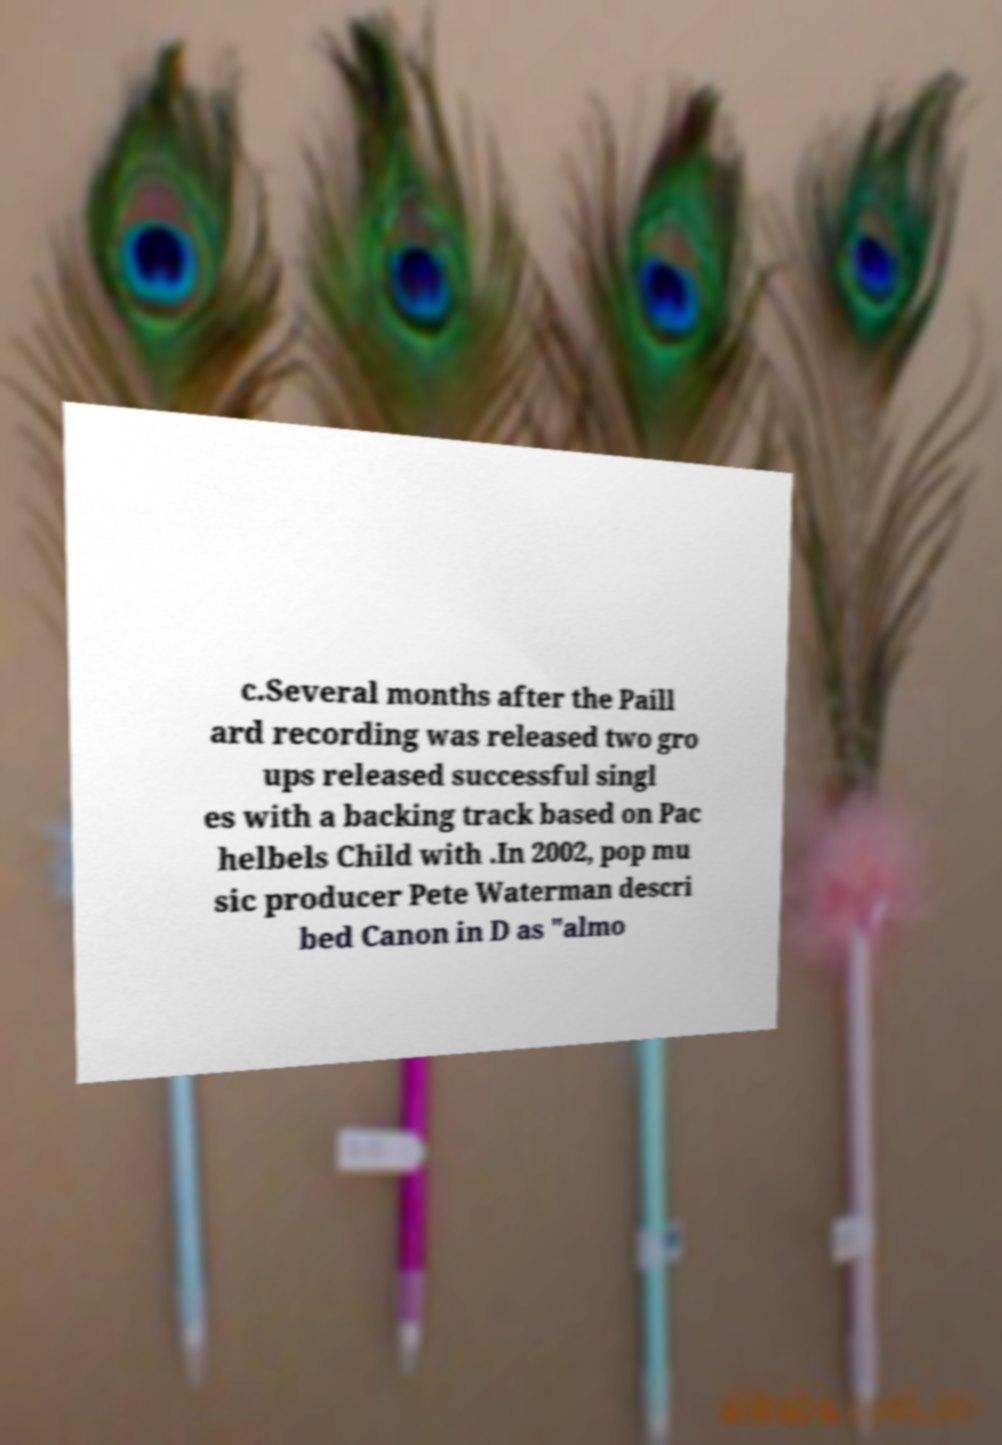Please read and relay the text visible in this image. What does it say? c.Several months after the Paill ard recording was released two gro ups released successful singl es with a backing track based on Pac helbels Child with .In 2002, pop mu sic producer Pete Waterman descri bed Canon in D as "almo 